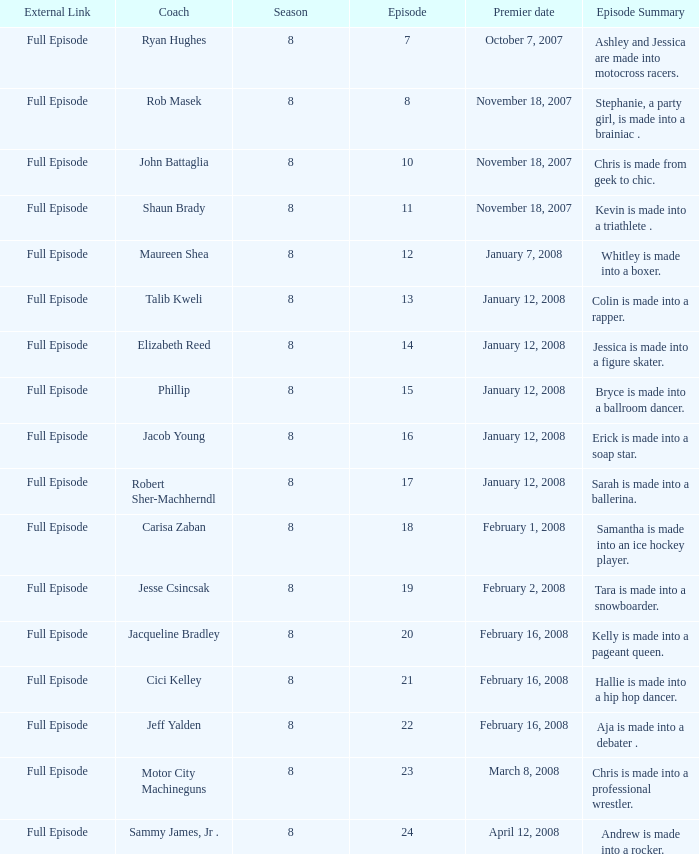Who was the coach for episode 15? Phillip. 